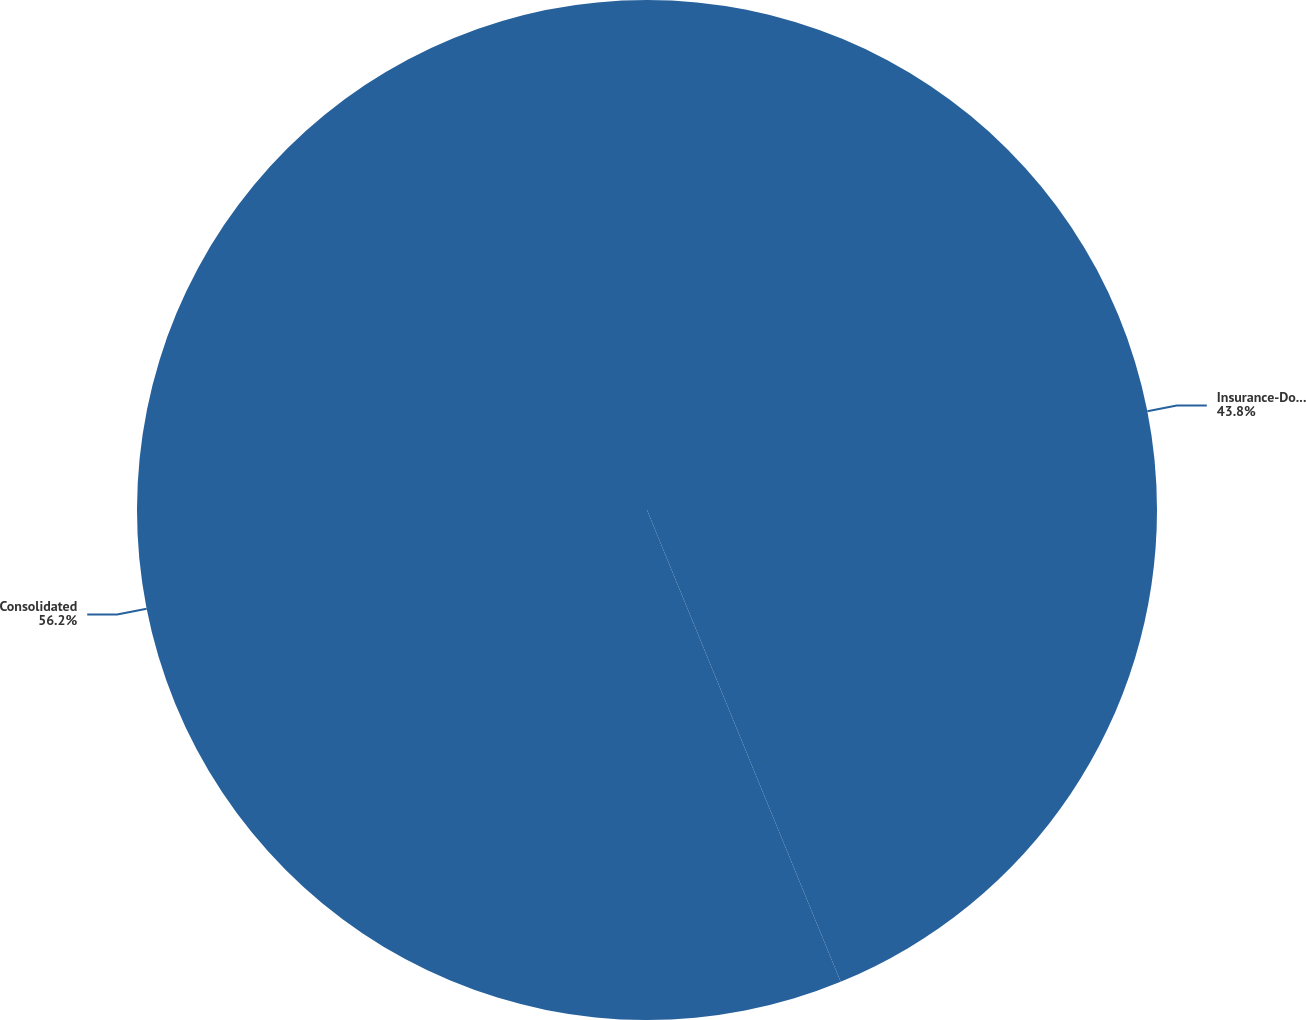<chart> <loc_0><loc_0><loc_500><loc_500><pie_chart><fcel>Insurance-Domestic<fcel>Consolidated<nl><fcel>43.8%<fcel>56.2%<nl></chart> 